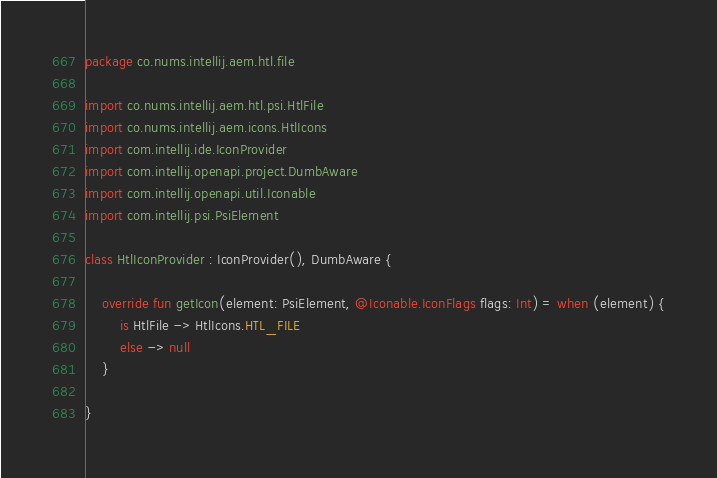Convert code to text. <code><loc_0><loc_0><loc_500><loc_500><_Kotlin_>package co.nums.intellij.aem.htl.file

import co.nums.intellij.aem.htl.psi.HtlFile
import co.nums.intellij.aem.icons.HtlIcons
import com.intellij.ide.IconProvider
import com.intellij.openapi.project.DumbAware
import com.intellij.openapi.util.Iconable
import com.intellij.psi.PsiElement

class HtlIconProvider : IconProvider(), DumbAware {

    override fun getIcon(element: PsiElement, @Iconable.IconFlags flags: Int) = when (element) {
        is HtlFile -> HtlIcons.HTL_FILE
        else -> null
    }

}
</code> 